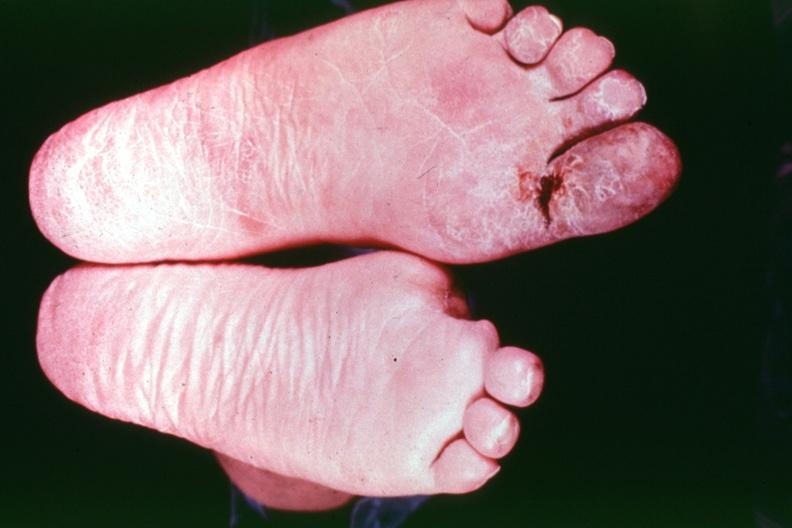s feet present?
Answer the question using a single word or phrase. Yes 